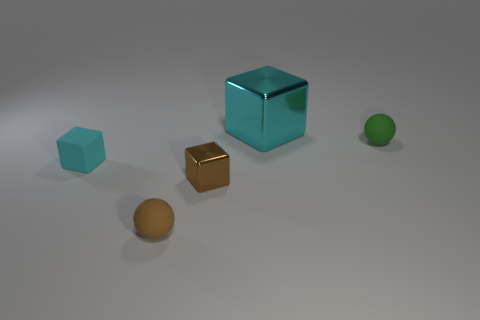Add 4 purple rubber cylinders. How many objects exist? 9 Subtract all balls. How many objects are left? 3 Add 1 tiny cyan blocks. How many tiny cyan blocks are left? 2 Add 1 small matte spheres. How many small matte spheres exist? 3 Subtract 0 blue cylinders. How many objects are left? 5 Subtract all tiny green metal cylinders. Subtract all small brown objects. How many objects are left? 3 